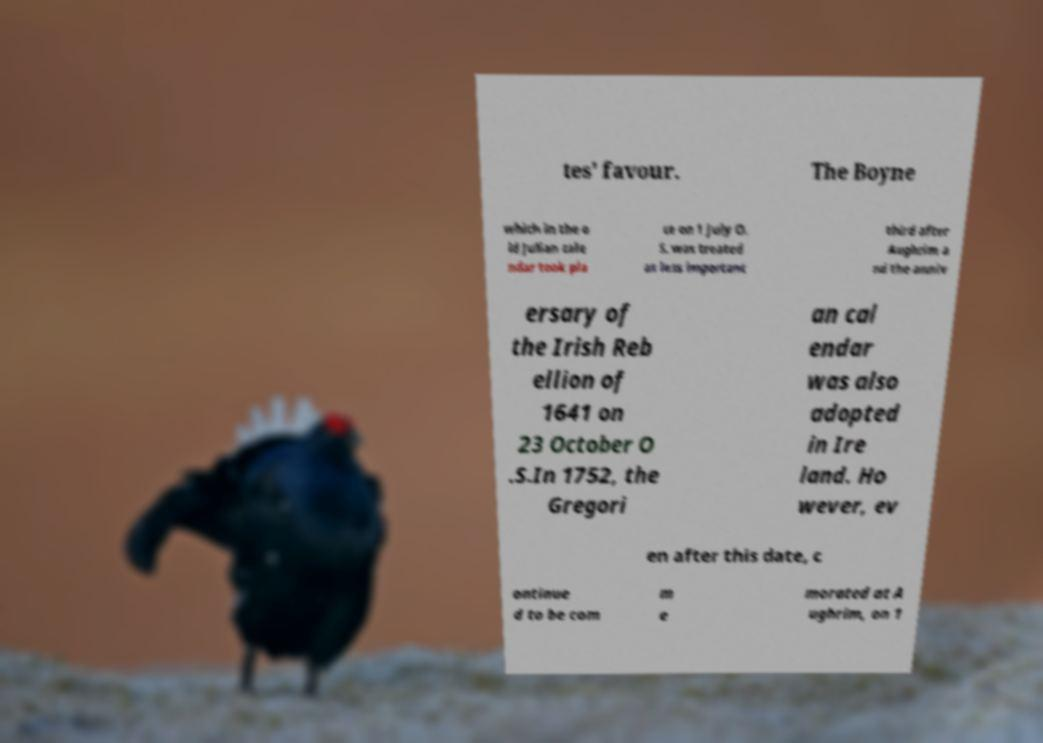Could you extract and type out the text from this image? tes' favour. The Boyne which in the o ld Julian cale ndar took pla ce on 1 July O. S. was treated as less important third after Aughrim a nd the anniv ersary of the Irish Reb ellion of 1641 on 23 October O .S.In 1752, the Gregori an cal endar was also adopted in Ire land. Ho wever, ev en after this date, c ontinue d to be com m e morated at A ughrim, on 1 